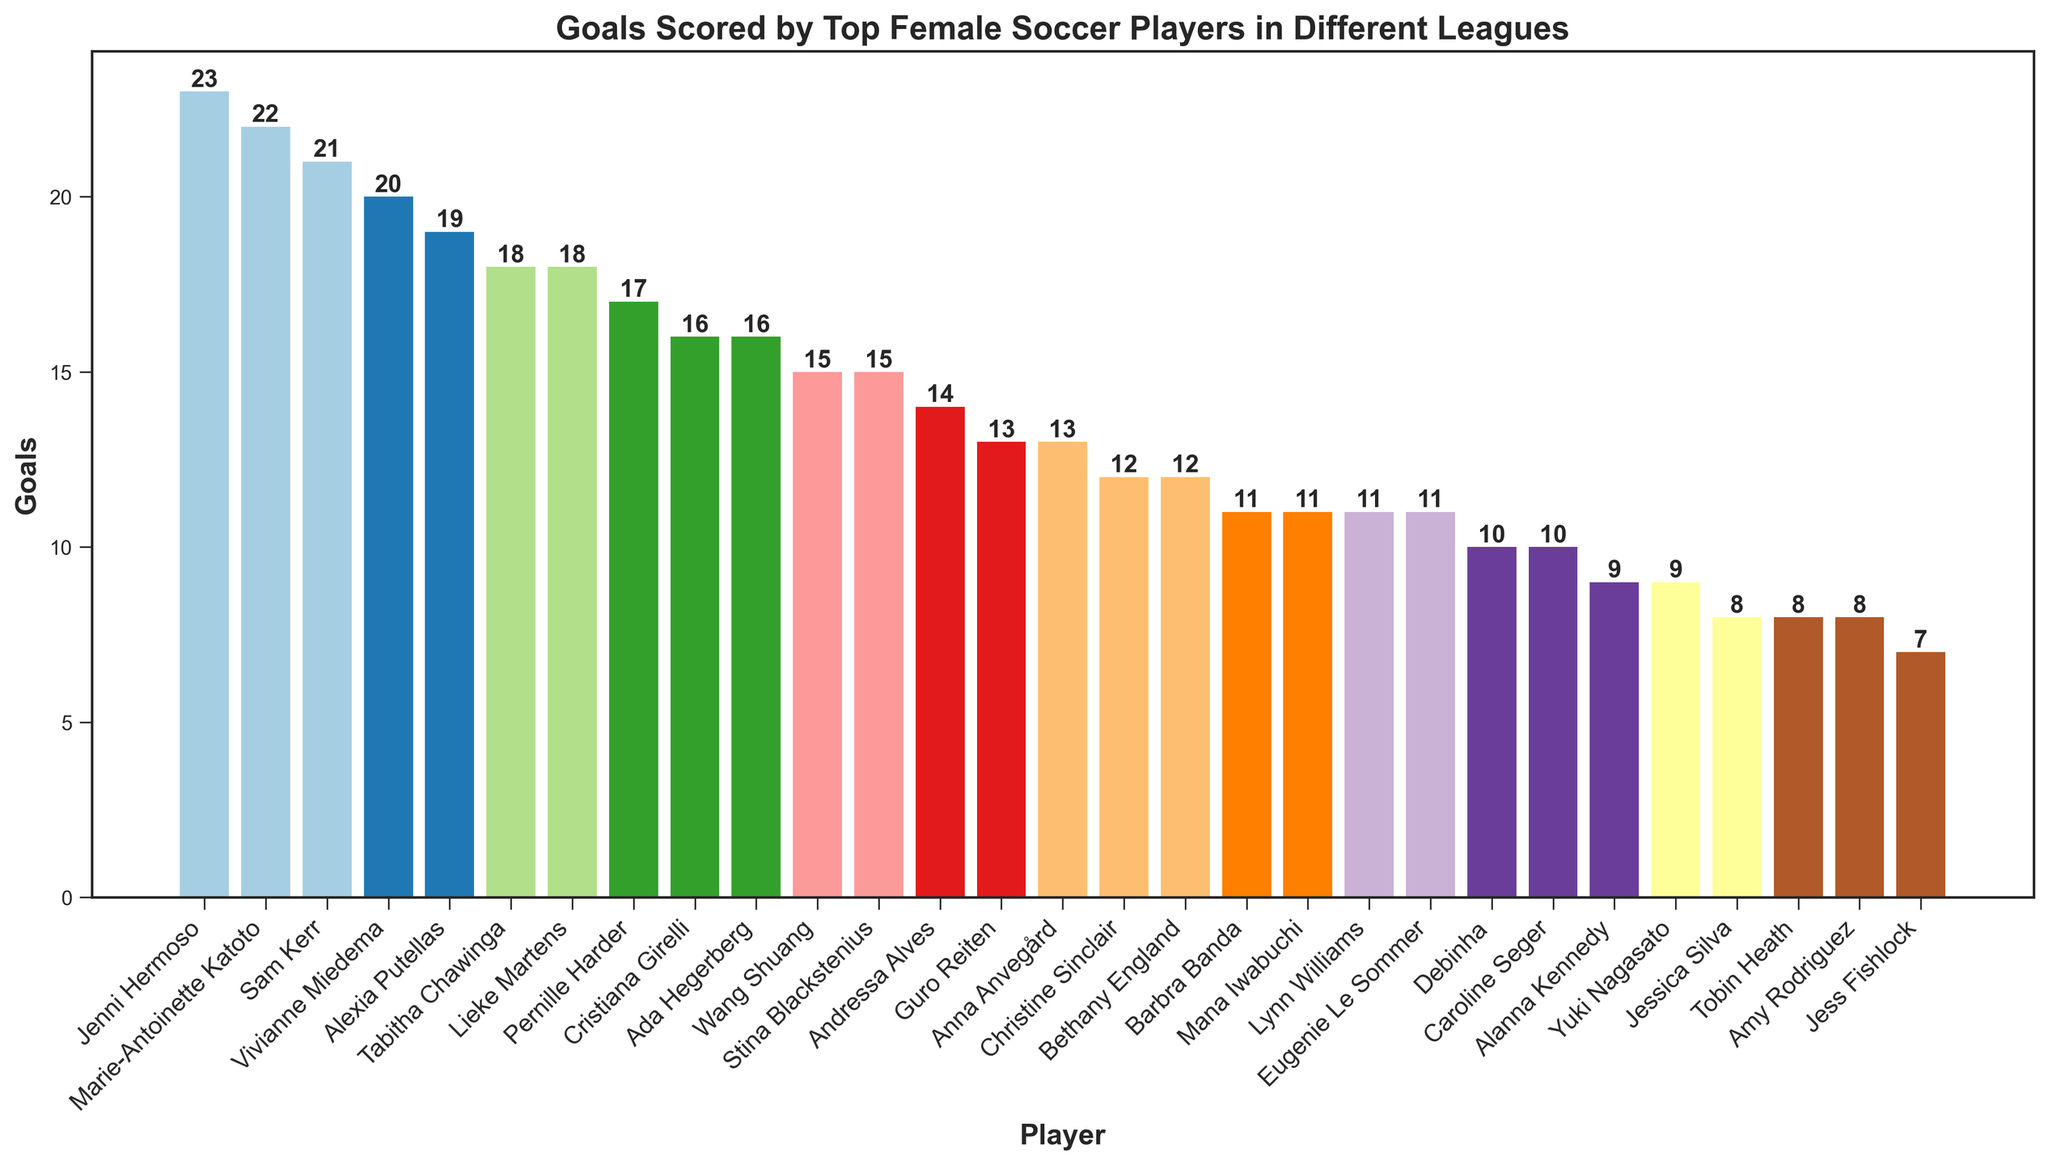Which player scored the most goals? Identify the tallest bar in the bar chart. The tallest bar belongs to Jenni Hermoso with 23 goals.
Answer: Jenni Hermoso How many total goals were scored by Sam Kerr and Vivianne Miedema in the FA Women's Super League? Sum the goals scored by Sam Kerr (21) and Vivianne Miedema (20) in the FA Women's Super League. 21 + 20 = 41.
Answer: 41 Which league has the most goals by a single player, and who is that player? Look for the player with the highest number of goals and note their league. Jenni Hermoso scored 23 goals in the Primera División Femenina.
Answer: Primera División Femenina, Jenni Hermoso What is the difference in goals scored between the top scorer in the NWSL and the top scorer in the FA Women's Super League? Identify the top scorer in the NWSL (Christine Sinclair, 12 goals) and the top scorer in the FA Women's Super League (Sam Kerr, 21 goals). Calculate the difference: 21 - 12 = 9.
Answer: 9 Who is the top scorer in the División 1 Féminine, and how many goals did she score? Find the player with the highest number of goals in the Division 1 Féminine. Marie-Antoinette Katoto is the top scorer with 22 goals.
Answer: Marie-Antoinette Katoto, 22 How many players scored 15 or more goals? Count the number of bars with a height of 15 or greater. These bars belong to 7 players: Sam Kerr, Vivianne Miedema, Pernille Harder, Lieke Martens, Jenni Hermoso, Alexia Putellas, and Marie-Antoinette Katoto.
Answer: 7 Which two players have scored exactly 11 goals each? Identify the players with bars corresponding to 11 goals. They are Barbra Banda and Mana Iwabuchi.
Answer: Barbra Banda, Mana Iwabuchi Among the players who scored in the Serie A Femminile, who scored the most goals? Locate the players in Serie A Femminile and identify the one with the highest number of goals. Tabitha Chawinga scored 18 goals.
Answer: Tabitha Chawinga What is the combined total of goals scored by Wang Shuang and Barbra Banda in the Chinese Women's Super League? Add the goals scored by Wang Shuang (15) and Barbra Banda (11). 15 + 11 = 26.
Answer: 26 Which player from the Damallsvenskan has the fewest goals, and how many did she score? Identify the players from Damallsvenskan and find the one with the shortest bar (least goals). Caroline Seger scored 10 goals, the fewest in Damallsvenskan.
Answer: Caroline Seger, 10 